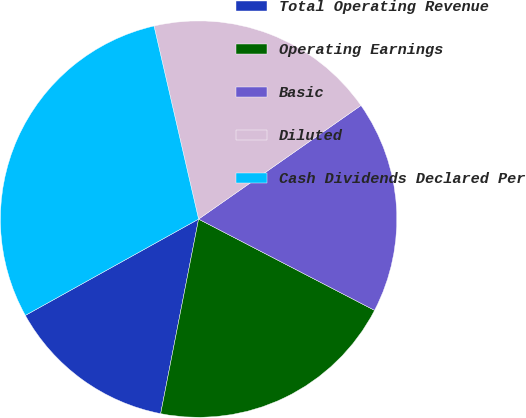Convert chart to OTSL. <chart><loc_0><loc_0><loc_500><loc_500><pie_chart><fcel>Total Operating Revenue<fcel>Operating Earnings<fcel>Basic<fcel>Diluted<fcel>Cash Dividends Declared Per<nl><fcel>13.86%<fcel>20.45%<fcel>17.33%<fcel>18.89%<fcel>29.46%<nl></chart> 